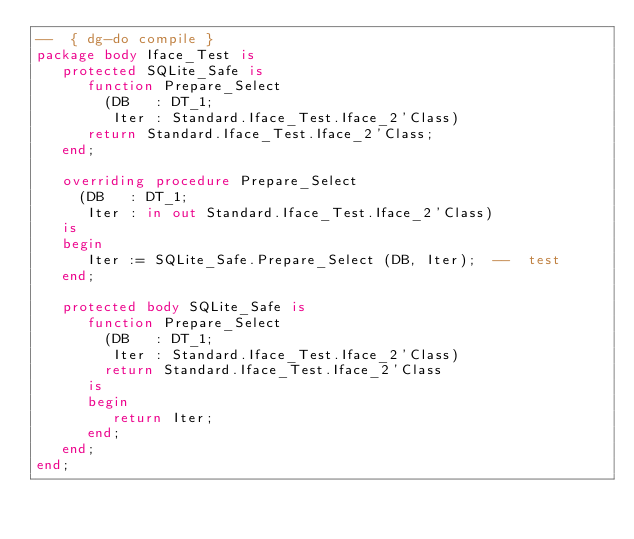<code> <loc_0><loc_0><loc_500><loc_500><_Ada_>--  { dg-do compile }
package body Iface_Test is
   protected SQLite_Safe is
      function Prepare_Select
        (DB   : DT_1;
         Iter : Standard.Iface_Test.Iface_2'Class)
      return Standard.Iface_Test.Iface_2'Class;
   end;

   overriding procedure Prepare_Select
     (DB   : DT_1;
      Iter : in out Standard.Iface_Test.Iface_2'Class)
   is
   begin
      Iter := SQLite_Safe.Prepare_Select (DB, Iter);  --  test
   end;

   protected body SQLite_Safe is
      function Prepare_Select
        (DB   : DT_1;
         Iter : Standard.Iface_Test.Iface_2'Class)
        return Standard.Iface_Test.Iface_2'Class
      is
      begin
         return Iter;
      end;
   end;
end;
</code> 